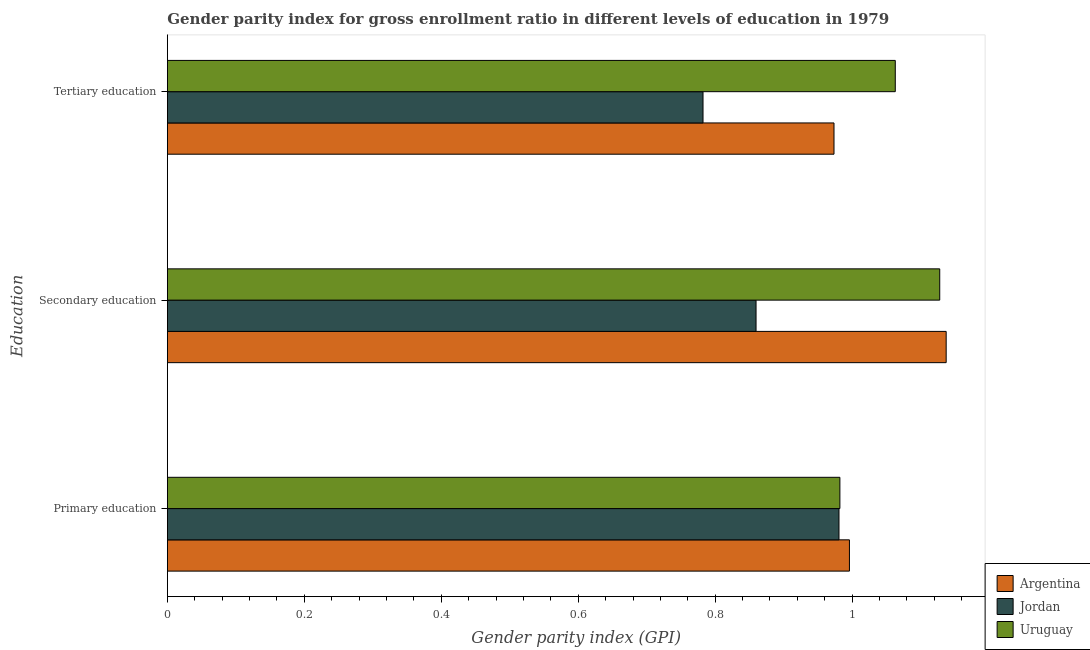How many groups of bars are there?
Your response must be concise. 3. How many bars are there on the 3rd tick from the top?
Give a very brief answer. 3. How many bars are there on the 1st tick from the bottom?
Make the answer very short. 3. What is the gender parity index in secondary education in Jordan?
Your response must be concise. 0.86. Across all countries, what is the maximum gender parity index in tertiary education?
Provide a short and direct response. 1.06. Across all countries, what is the minimum gender parity index in tertiary education?
Ensure brevity in your answer.  0.78. In which country was the gender parity index in tertiary education minimum?
Give a very brief answer. Jordan. What is the total gender parity index in secondary education in the graph?
Your answer should be very brief. 3.12. What is the difference between the gender parity index in secondary education in Uruguay and that in Argentina?
Ensure brevity in your answer.  -0.01. What is the difference between the gender parity index in primary education in Uruguay and the gender parity index in tertiary education in Argentina?
Provide a short and direct response. 0.01. What is the average gender parity index in secondary education per country?
Your answer should be compact. 1.04. What is the difference between the gender parity index in primary education and gender parity index in tertiary education in Jordan?
Offer a terse response. 0.2. In how many countries, is the gender parity index in primary education greater than 0.7200000000000001 ?
Provide a succinct answer. 3. What is the ratio of the gender parity index in secondary education in Jordan to that in Argentina?
Offer a very short reply. 0.76. Is the gender parity index in tertiary education in Uruguay less than that in Jordan?
Keep it short and to the point. No. What is the difference between the highest and the second highest gender parity index in tertiary education?
Provide a short and direct response. 0.09. What is the difference between the highest and the lowest gender parity index in primary education?
Ensure brevity in your answer.  0.02. Is the sum of the gender parity index in tertiary education in Argentina and Uruguay greater than the maximum gender parity index in secondary education across all countries?
Keep it short and to the point. Yes. What does the 2nd bar from the top in Primary education represents?
Offer a very short reply. Jordan. How many bars are there?
Provide a succinct answer. 9. What is the difference between two consecutive major ticks on the X-axis?
Keep it short and to the point. 0.2. Are the values on the major ticks of X-axis written in scientific E-notation?
Your response must be concise. No. Does the graph contain grids?
Your answer should be compact. No. How many legend labels are there?
Your answer should be very brief. 3. How are the legend labels stacked?
Provide a short and direct response. Vertical. What is the title of the graph?
Provide a short and direct response. Gender parity index for gross enrollment ratio in different levels of education in 1979. Does "Cote d'Ivoire" appear as one of the legend labels in the graph?
Your response must be concise. No. What is the label or title of the X-axis?
Offer a terse response. Gender parity index (GPI). What is the label or title of the Y-axis?
Offer a terse response. Education. What is the Gender parity index (GPI) of Argentina in Primary education?
Provide a succinct answer. 1. What is the Gender parity index (GPI) of Jordan in Primary education?
Give a very brief answer. 0.98. What is the Gender parity index (GPI) of Uruguay in Primary education?
Make the answer very short. 0.98. What is the Gender parity index (GPI) of Argentina in Secondary education?
Your answer should be very brief. 1.14. What is the Gender parity index (GPI) of Jordan in Secondary education?
Give a very brief answer. 0.86. What is the Gender parity index (GPI) of Uruguay in Secondary education?
Make the answer very short. 1.13. What is the Gender parity index (GPI) of Argentina in Tertiary education?
Provide a succinct answer. 0.97. What is the Gender parity index (GPI) in Jordan in Tertiary education?
Provide a succinct answer. 0.78. What is the Gender parity index (GPI) in Uruguay in Tertiary education?
Your response must be concise. 1.06. Across all Education, what is the maximum Gender parity index (GPI) in Argentina?
Ensure brevity in your answer.  1.14. Across all Education, what is the maximum Gender parity index (GPI) in Jordan?
Provide a short and direct response. 0.98. Across all Education, what is the maximum Gender parity index (GPI) in Uruguay?
Give a very brief answer. 1.13. Across all Education, what is the minimum Gender parity index (GPI) in Argentina?
Offer a terse response. 0.97. Across all Education, what is the minimum Gender parity index (GPI) in Jordan?
Your response must be concise. 0.78. Across all Education, what is the minimum Gender parity index (GPI) in Uruguay?
Provide a succinct answer. 0.98. What is the total Gender parity index (GPI) of Argentina in the graph?
Provide a short and direct response. 3.11. What is the total Gender parity index (GPI) of Jordan in the graph?
Your answer should be compact. 2.62. What is the total Gender parity index (GPI) of Uruguay in the graph?
Make the answer very short. 3.17. What is the difference between the Gender parity index (GPI) in Argentina in Primary education and that in Secondary education?
Provide a short and direct response. -0.14. What is the difference between the Gender parity index (GPI) in Jordan in Primary education and that in Secondary education?
Make the answer very short. 0.12. What is the difference between the Gender parity index (GPI) in Uruguay in Primary education and that in Secondary education?
Offer a very short reply. -0.15. What is the difference between the Gender parity index (GPI) of Argentina in Primary education and that in Tertiary education?
Provide a succinct answer. 0.02. What is the difference between the Gender parity index (GPI) of Jordan in Primary education and that in Tertiary education?
Make the answer very short. 0.2. What is the difference between the Gender parity index (GPI) in Uruguay in Primary education and that in Tertiary education?
Offer a terse response. -0.08. What is the difference between the Gender parity index (GPI) in Argentina in Secondary education and that in Tertiary education?
Provide a short and direct response. 0.16. What is the difference between the Gender parity index (GPI) in Jordan in Secondary education and that in Tertiary education?
Give a very brief answer. 0.08. What is the difference between the Gender parity index (GPI) of Uruguay in Secondary education and that in Tertiary education?
Provide a short and direct response. 0.06. What is the difference between the Gender parity index (GPI) of Argentina in Primary education and the Gender parity index (GPI) of Jordan in Secondary education?
Your response must be concise. 0.14. What is the difference between the Gender parity index (GPI) of Argentina in Primary education and the Gender parity index (GPI) of Uruguay in Secondary education?
Offer a terse response. -0.13. What is the difference between the Gender parity index (GPI) in Jordan in Primary education and the Gender parity index (GPI) in Uruguay in Secondary education?
Your answer should be very brief. -0.15. What is the difference between the Gender parity index (GPI) of Argentina in Primary education and the Gender parity index (GPI) of Jordan in Tertiary education?
Your answer should be very brief. 0.21. What is the difference between the Gender parity index (GPI) of Argentina in Primary education and the Gender parity index (GPI) of Uruguay in Tertiary education?
Ensure brevity in your answer.  -0.07. What is the difference between the Gender parity index (GPI) of Jordan in Primary education and the Gender parity index (GPI) of Uruguay in Tertiary education?
Ensure brevity in your answer.  -0.08. What is the difference between the Gender parity index (GPI) in Argentina in Secondary education and the Gender parity index (GPI) in Jordan in Tertiary education?
Your answer should be very brief. 0.36. What is the difference between the Gender parity index (GPI) of Argentina in Secondary education and the Gender parity index (GPI) of Uruguay in Tertiary education?
Give a very brief answer. 0.07. What is the difference between the Gender parity index (GPI) in Jordan in Secondary education and the Gender parity index (GPI) in Uruguay in Tertiary education?
Your answer should be very brief. -0.2. What is the average Gender parity index (GPI) of Argentina per Education?
Ensure brevity in your answer.  1.04. What is the average Gender parity index (GPI) in Jordan per Education?
Keep it short and to the point. 0.87. What is the average Gender parity index (GPI) of Uruguay per Education?
Ensure brevity in your answer.  1.06. What is the difference between the Gender parity index (GPI) of Argentina and Gender parity index (GPI) of Jordan in Primary education?
Offer a terse response. 0.02. What is the difference between the Gender parity index (GPI) in Argentina and Gender parity index (GPI) in Uruguay in Primary education?
Your answer should be very brief. 0.01. What is the difference between the Gender parity index (GPI) of Jordan and Gender parity index (GPI) of Uruguay in Primary education?
Ensure brevity in your answer.  -0. What is the difference between the Gender parity index (GPI) of Argentina and Gender parity index (GPI) of Jordan in Secondary education?
Provide a short and direct response. 0.28. What is the difference between the Gender parity index (GPI) of Argentina and Gender parity index (GPI) of Uruguay in Secondary education?
Make the answer very short. 0.01. What is the difference between the Gender parity index (GPI) in Jordan and Gender parity index (GPI) in Uruguay in Secondary education?
Provide a succinct answer. -0.27. What is the difference between the Gender parity index (GPI) in Argentina and Gender parity index (GPI) in Jordan in Tertiary education?
Make the answer very short. 0.19. What is the difference between the Gender parity index (GPI) in Argentina and Gender parity index (GPI) in Uruguay in Tertiary education?
Keep it short and to the point. -0.09. What is the difference between the Gender parity index (GPI) of Jordan and Gender parity index (GPI) of Uruguay in Tertiary education?
Keep it short and to the point. -0.28. What is the ratio of the Gender parity index (GPI) of Argentina in Primary education to that in Secondary education?
Your response must be concise. 0.88. What is the ratio of the Gender parity index (GPI) in Jordan in Primary education to that in Secondary education?
Your response must be concise. 1.14. What is the ratio of the Gender parity index (GPI) of Uruguay in Primary education to that in Secondary education?
Keep it short and to the point. 0.87. What is the ratio of the Gender parity index (GPI) of Argentina in Primary education to that in Tertiary education?
Your answer should be compact. 1.02. What is the ratio of the Gender parity index (GPI) of Jordan in Primary education to that in Tertiary education?
Your answer should be very brief. 1.25. What is the ratio of the Gender parity index (GPI) in Uruguay in Primary education to that in Tertiary education?
Your answer should be compact. 0.92. What is the ratio of the Gender parity index (GPI) in Argentina in Secondary education to that in Tertiary education?
Offer a very short reply. 1.17. What is the ratio of the Gender parity index (GPI) of Jordan in Secondary education to that in Tertiary education?
Ensure brevity in your answer.  1.1. What is the ratio of the Gender parity index (GPI) of Uruguay in Secondary education to that in Tertiary education?
Your answer should be compact. 1.06. What is the difference between the highest and the second highest Gender parity index (GPI) in Argentina?
Ensure brevity in your answer.  0.14. What is the difference between the highest and the second highest Gender parity index (GPI) in Jordan?
Provide a succinct answer. 0.12. What is the difference between the highest and the second highest Gender parity index (GPI) in Uruguay?
Your answer should be compact. 0.06. What is the difference between the highest and the lowest Gender parity index (GPI) in Argentina?
Your answer should be very brief. 0.16. What is the difference between the highest and the lowest Gender parity index (GPI) in Jordan?
Your answer should be compact. 0.2. What is the difference between the highest and the lowest Gender parity index (GPI) in Uruguay?
Offer a very short reply. 0.15. 